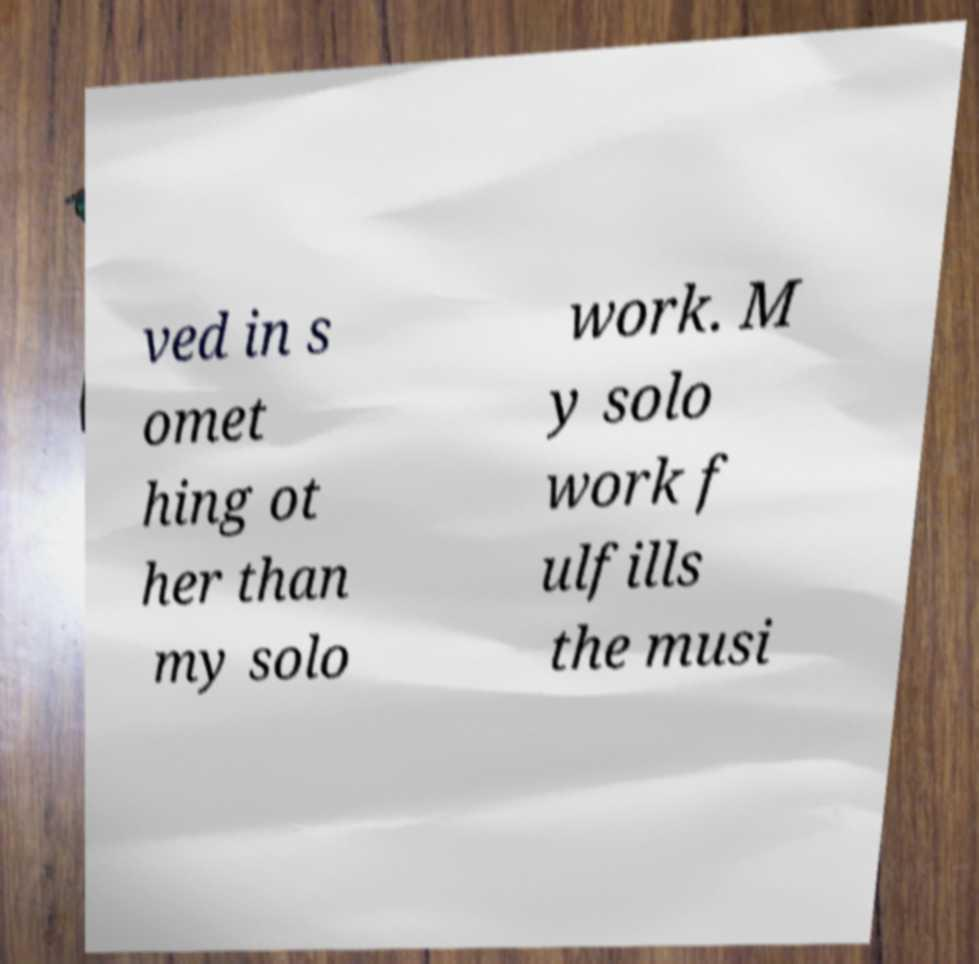Please identify and transcribe the text found in this image. ved in s omet hing ot her than my solo work. M y solo work f ulfills the musi 